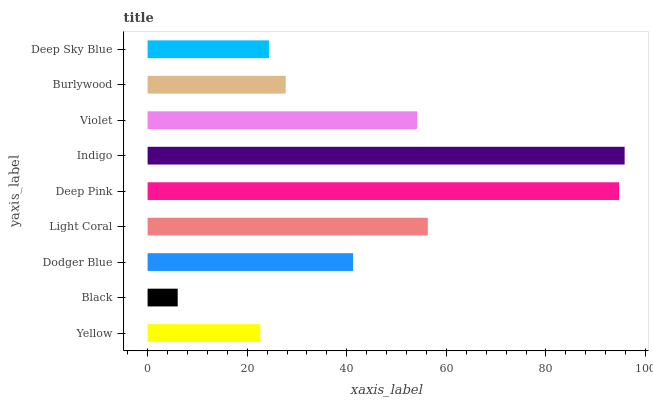Is Black the minimum?
Answer yes or no. Yes. Is Indigo the maximum?
Answer yes or no. Yes. Is Dodger Blue the minimum?
Answer yes or no. No. Is Dodger Blue the maximum?
Answer yes or no. No. Is Dodger Blue greater than Black?
Answer yes or no. Yes. Is Black less than Dodger Blue?
Answer yes or no. Yes. Is Black greater than Dodger Blue?
Answer yes or no. No. Is Dodger Blue less than Black?
Answer yes or no. No. Is Dodger Blue the high median?
Answer yes or no. Yes. Is Dodger Blue the low median?
Answer yes or no. Yes. Is Black the high median?
Answer yes or no. No. Is Light Coral the low median?
Answer yes or no. No. 